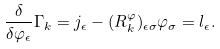Convert formula to latex. <formula><loc_0><loc_0><loc_500><loc_500>\frac { \delta } { \delta \varphi _ { \epsilon } } \Gamma _ { k } = j _ { \epsilon } - ( R _ { k } ^ { \varphi } ) _ { \epsilon \sigma } \varphi _ { \sigma } = l _ { \epsilon } .</formula> 